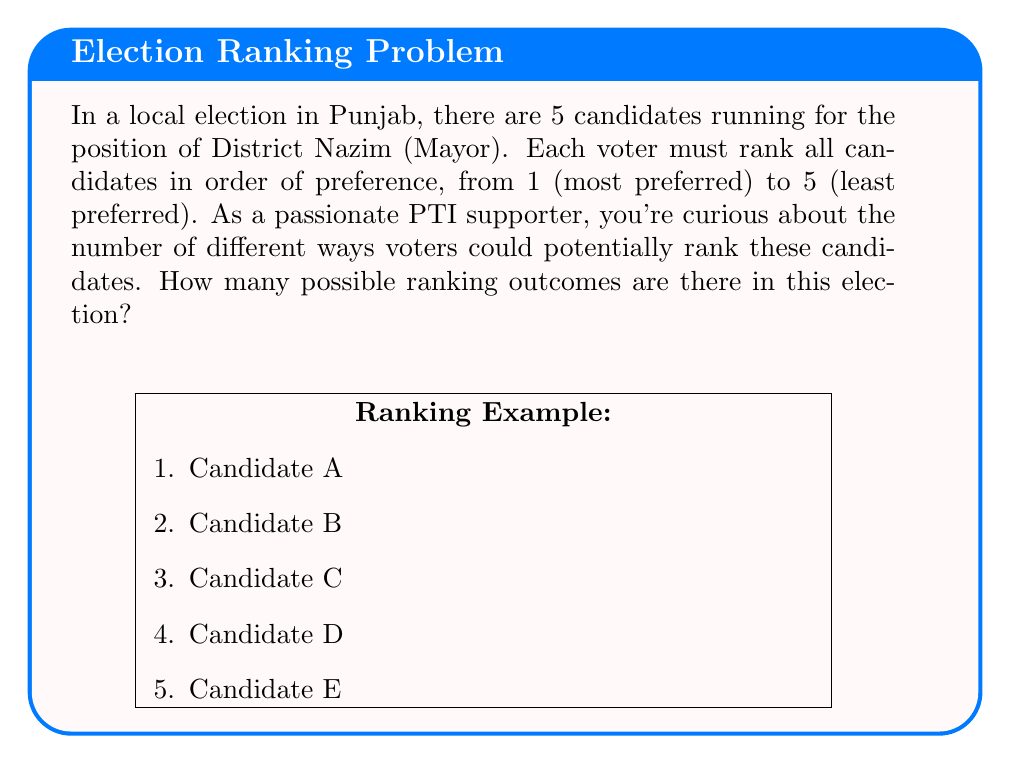Solve this math problem. Let's approach this step-by-step using combinatorics:

1) This is a permutation problem. We need to arrange 5 candidates in a specific order.

2) For the first position, we have 5 choices.

3) For the second position, we have 4 remaining choices.

4) For the third position, we have 3 remaining choices.

5) For the fourth position, we have 2 remaining choices.

6) For the last position, we have only 1 choice left.

7) According to the multiplication principle, we multiply these numbers:

   $$5 \times 4 \times 3 \times 2 \times 1 = 120$$

8) This is also known as 5 factorial, denoted as 5!:

   $$5! = 5 \times 4 \times 3 \times 2 \times 1 = 120$$

Therefore, there are 120 possible ways to rank the 5 candidates.
Answer: 120 